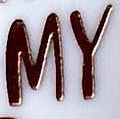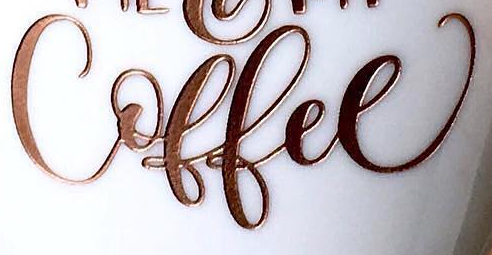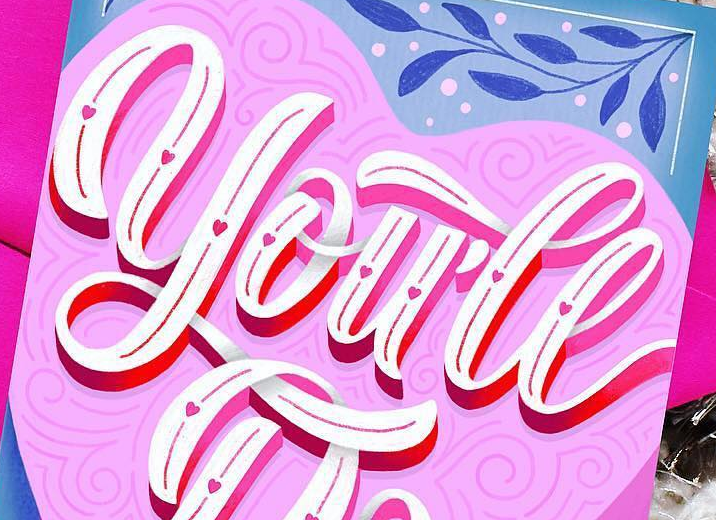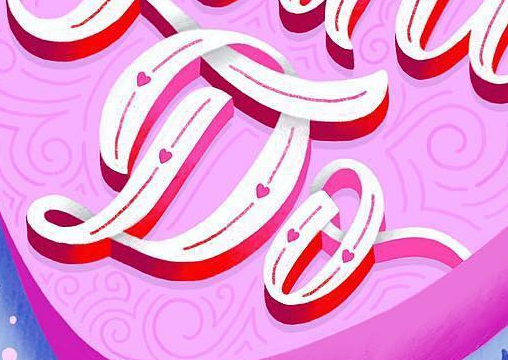What words are shown in these images in order, separated by a semicolon? MY; Coffee; you'll; Do 